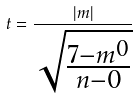Convert formula to latex. <formula><loc_0><loc_0><loc_500><loc_500>t = \frac { | m | } { \sqrt { \frac { 7 - m ^ { 0 } } { n - 0 } } }</formula> 